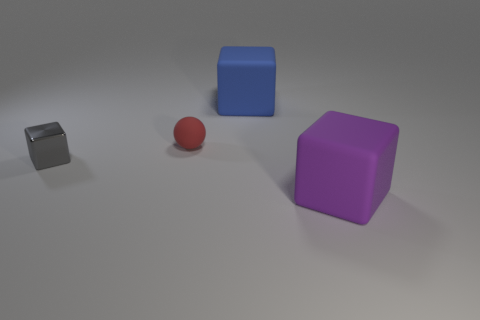Add 3 large rubber blocks. How many objects exist? 7 Subtract all balls. How many objects are left? 3 Add 2 cubes. How many cubes are left? 5 Add 1 yellow matte spheres. How many yellow matte spheres exist? 1 Subtract 0 cyan cylinders. How many objects are left? 4 Subtract all large purple things. Subtract all tiny gray things. How many objects are left? 2 